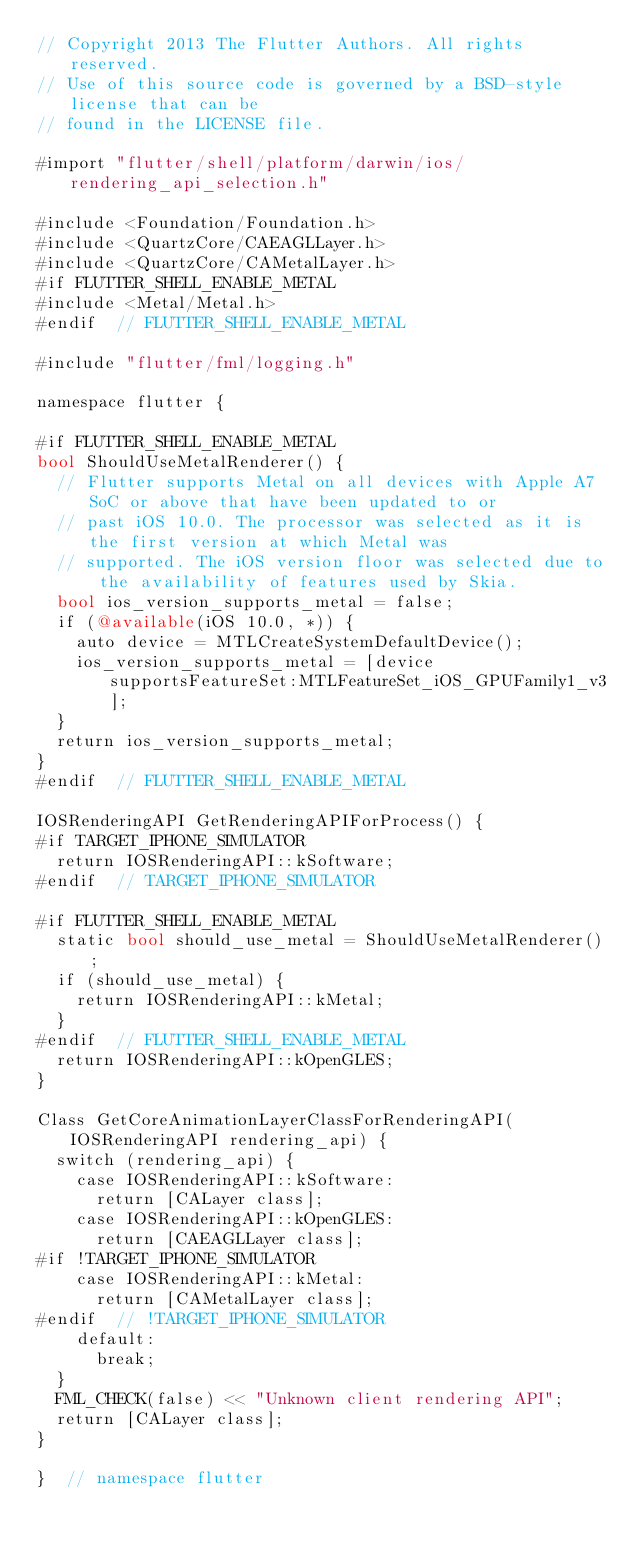Convert code to text. <code><loc_0><loc_0><loc_500><loc_500><_ObjectiveC_>// Copyright 2013 The Flutter Authors. All rights reserved.
// Use of this source code is governed by a BSD-style license that can be
// found in the LICENSE file.

#import "flutter/shell/platform/darwin/ios/rendering_api_selection.h"

#include <Foundation/Foundation.h>
#include <QuartzCore/CAEAGLLayer.h>
#include <QuartzCore/CAMetalLayer.h>
#if FLUTTER_SHELL_ENABLE_METAL
#include <Metal/Metal.h>
#endif  // FLUTTER_SHELL_ENABLE_METAL

#include "flutter/fml/logging.h"

namespace flutter {

#if FLUTTER_SHELL_ENABLE_METAL
bool ShouldUseMetalRenderer() {
  // Flutter supports Metal on all devices with Apple A7 SoC or above that have been updated to or
  // past iOS 10.0. The processor was selected as it is the first version at which Metal was
  // supported. The iOS version floor was selected due to the availability of features used by Skia.
  bool ios_version_supports_metal = false;
  if (@available(iOS 10.0, *)) {
    auto device = MTLCreateSystemDefaultDevice();
    ios_version_supports_metal = [device supportsFeatureSet:MTLFeatureSet_iOS_GPUFamily1_v3];
  }
  return ios_version_supports_metal;
}
#endif  // FLUTTER_SHELL_ENABLE_METAL

IOSRenderingAPI GetRenderingAPIForProcess() {
#if TARGET_IPHONE_SIMULATOR
  return IOSRenderingAPI::kSoftware;
#endif  // TARGET_IPHONE_SIMULATOR

#if FLUTTER_SHELL_ENABLE_METAL
  static bool should_use_metal = ShouldUseMetalRenderer();
  if (should_use_metal) {
    return IOSRenderingAPI::kMetal;
  }
#endif  // FLUTTER_SHELL_ENABLE_METAL
  return IOSRenderingAPI::kOpenGLES;
}

Class GetCoreAnimationLayerClassForRenderingAPI(IOSRenderingAPI rendering_api) {
  switch (rendering_api) {
    case IOSRenderingAPI::kSoftware:
      return [CALayer class];
    case IOSRenderingAPI::kOpenGLES:
      return [CAEAGLLayer class];
#if !TARGET_IPHONE_SIMULATOR
    case IOSRenderingAPI::kMetal:
      return [CAMetalLayer class];
#endif  // !TARGET_IPHONE_SIMULATOR
    default:
      break;
  }
  FML_CHECK(false) << "Unknown client rendering API";
  return [CALayer class];
}

}  // namespace flutter
</code> 